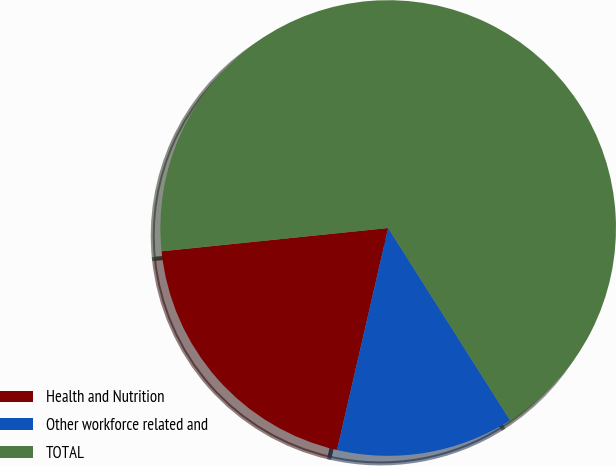Convert chart to OTSL. <chart><loc_0><loc_0><loc_500><loc_500><pie_chart><fcel>Health and Nutrition<fcel>Other workforce related and<fcel>TOTAL<nl><fcel>19.77%<fcel>12.6%<fcel>67.64%<nl></chart> 